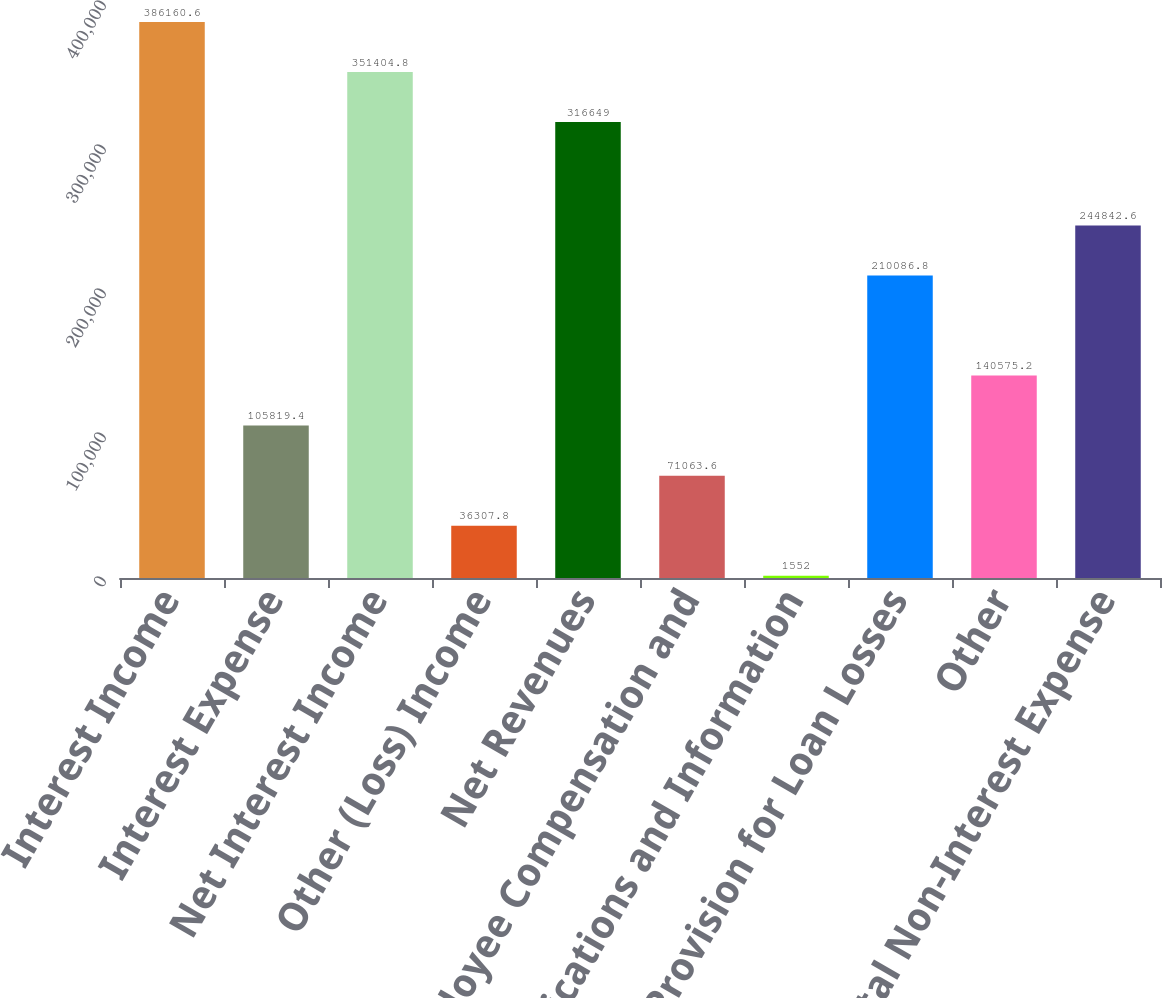Convert chart to OTSL. <chart><loc_0><loc_0><loc_500><loc_500><bar_chart><fcel>Interest Income<fcel>Interest Expense<fcel>Net Interest Income<fcel>Other (Loss) Income<fcel>Net Revenues<fcel>Employee Compensation and<fcel>Communications and Information<fcel>Provision for Loan Losses<fcel>Other<fcel>Total Non-Interest Expense<nl><fcel>386161<fcel>105819<fcel>351405<fcel>36307.8<fcel>316649<fcel>71063.6<fcel>1552<fcel>210087<fcel>140575<fcel>244843<nl></chart> 